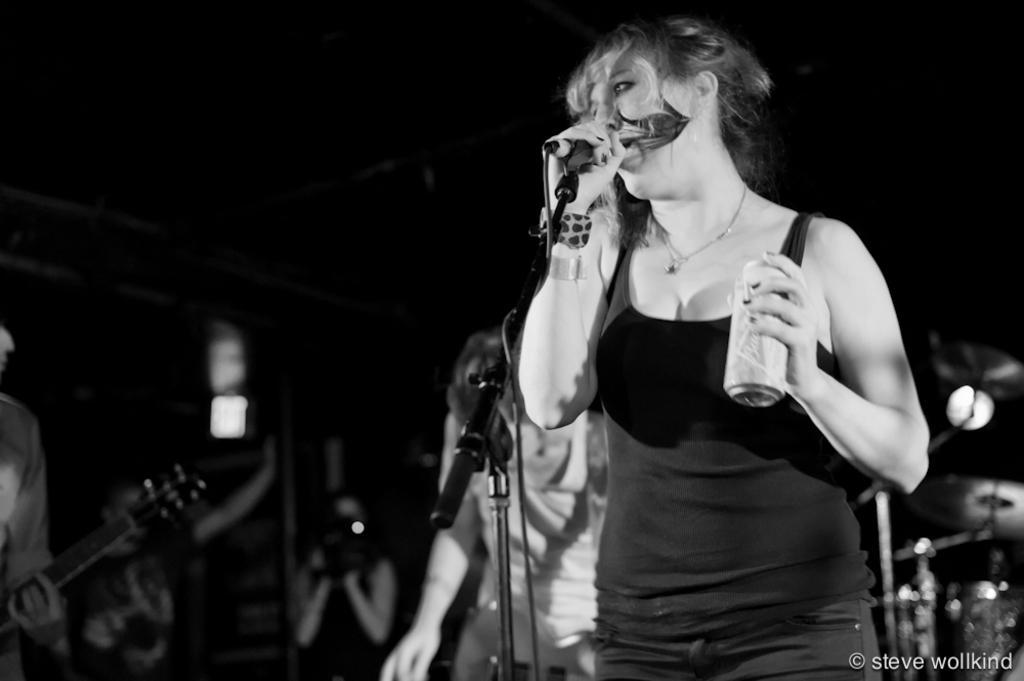Describe this image in one or two sentences. Woman in black t-shirt is holding microphone in one of her hand and singing on it, on the other hand she is holding coke bottle. Beside behind him, man in white t-shirt is standing and in front of him, we even see a microphone and this picture is taken in dark and it is a black and white picture. 